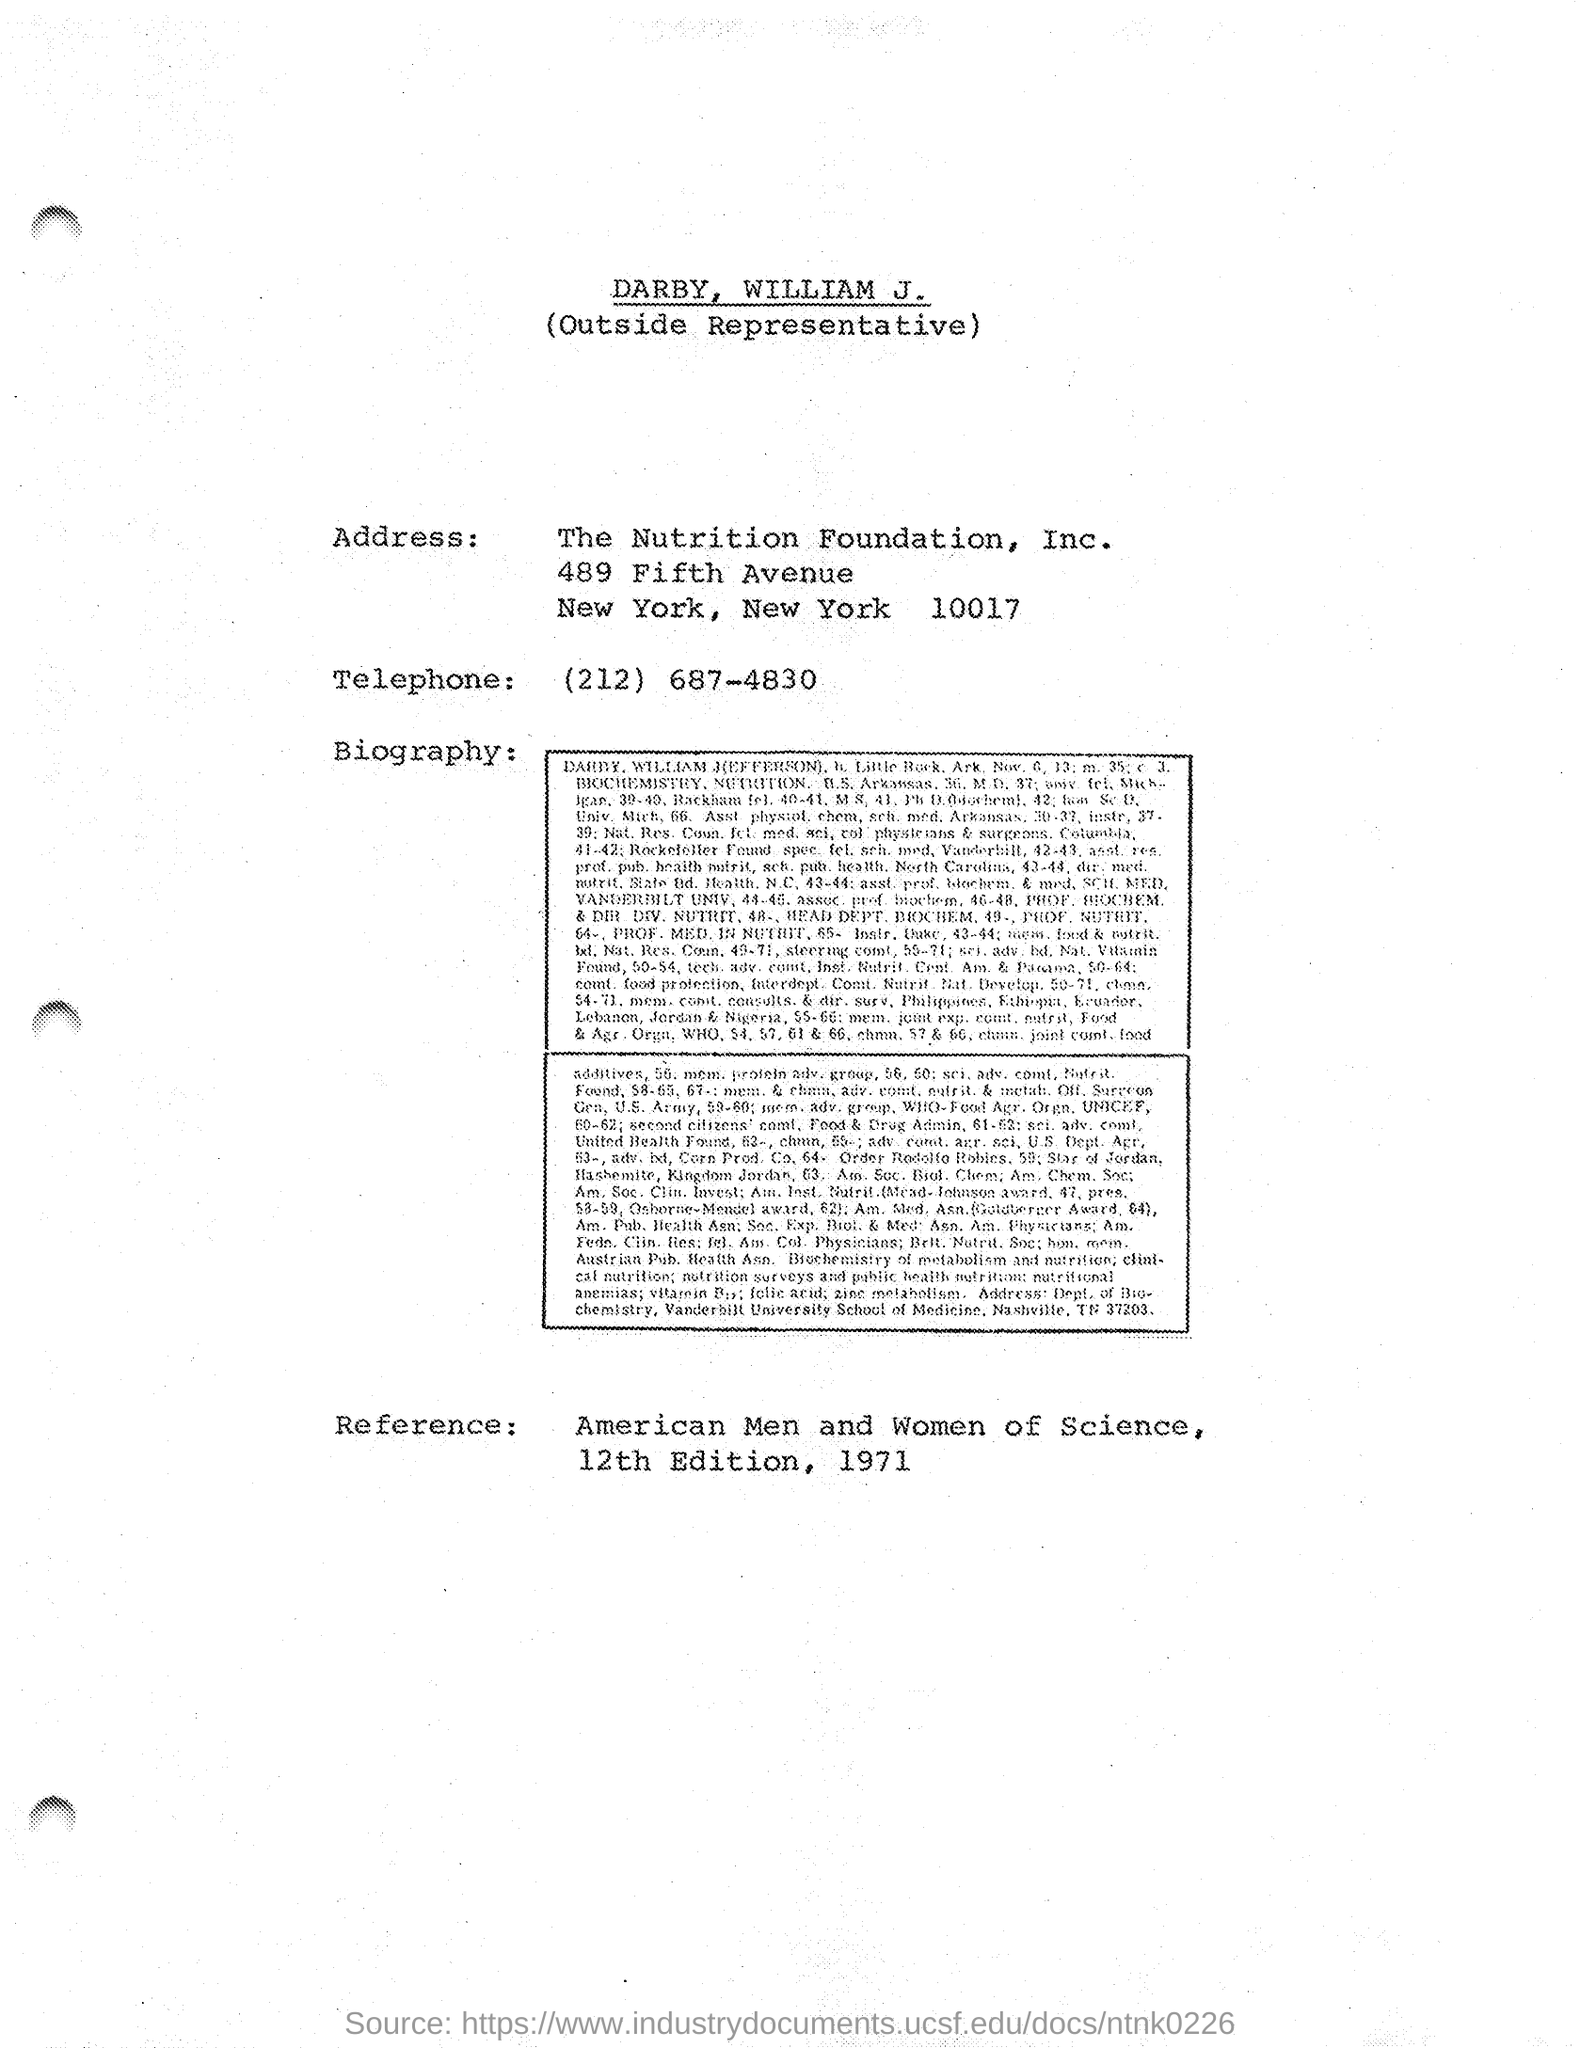Who is the representative of this foundation?
Offer a terse response. DARBY, WILLIAM J. Who is the Reference given to this foundation?
Give a very brief answer. American Men and Women of Science. 